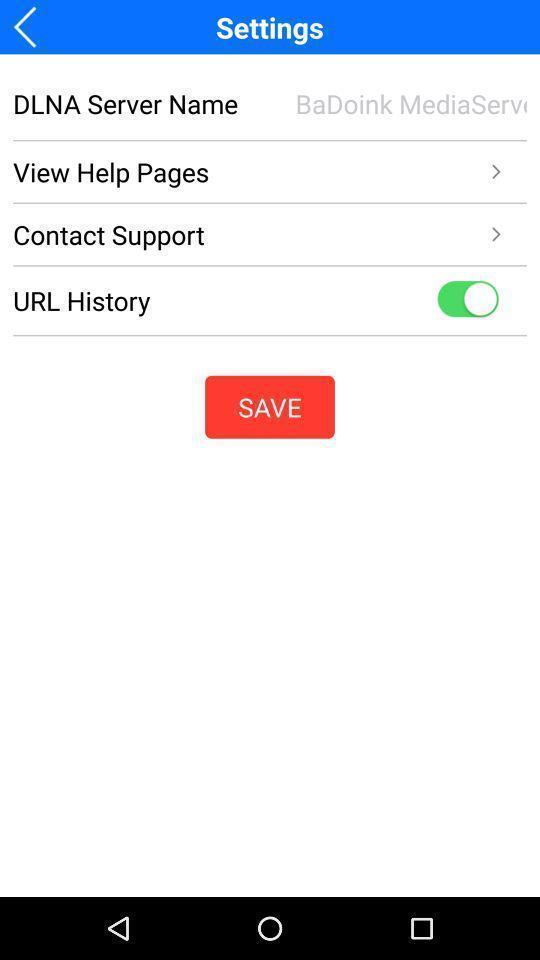Give me a summary of this screen capture. Settings page with various other options. 